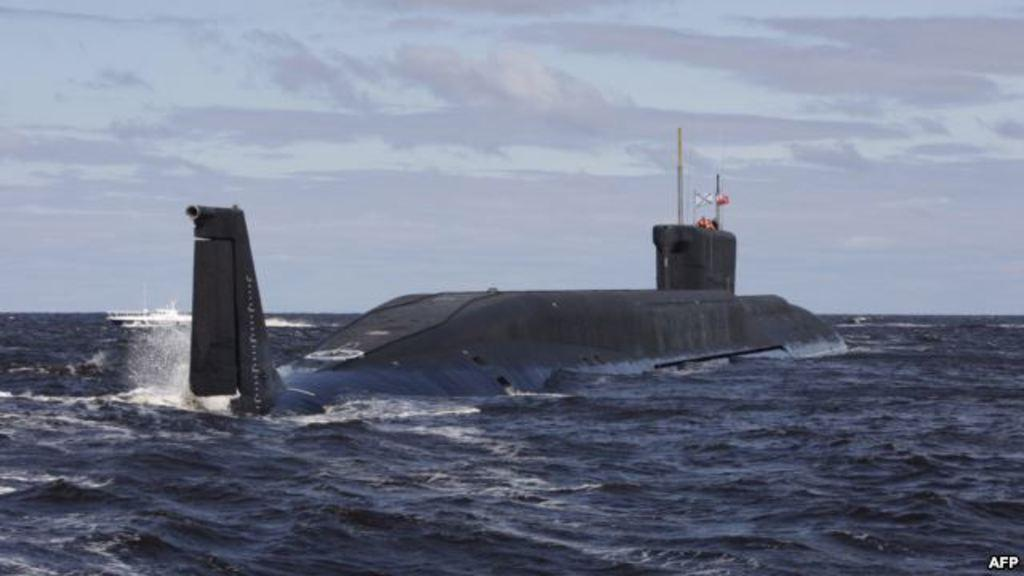What is at the bottom of the image? There is water at the bottom of the image. What is located above the water in the image? A submarine and a ship are both visible above the water. What can be seen in the sky at the top of the image? There are clouds in the sky at the top of the image. What type of light can be seen coming from the chicken in the image? There is no chicken present in the image, so it is not possible to determine what type of light might be coming from it. 